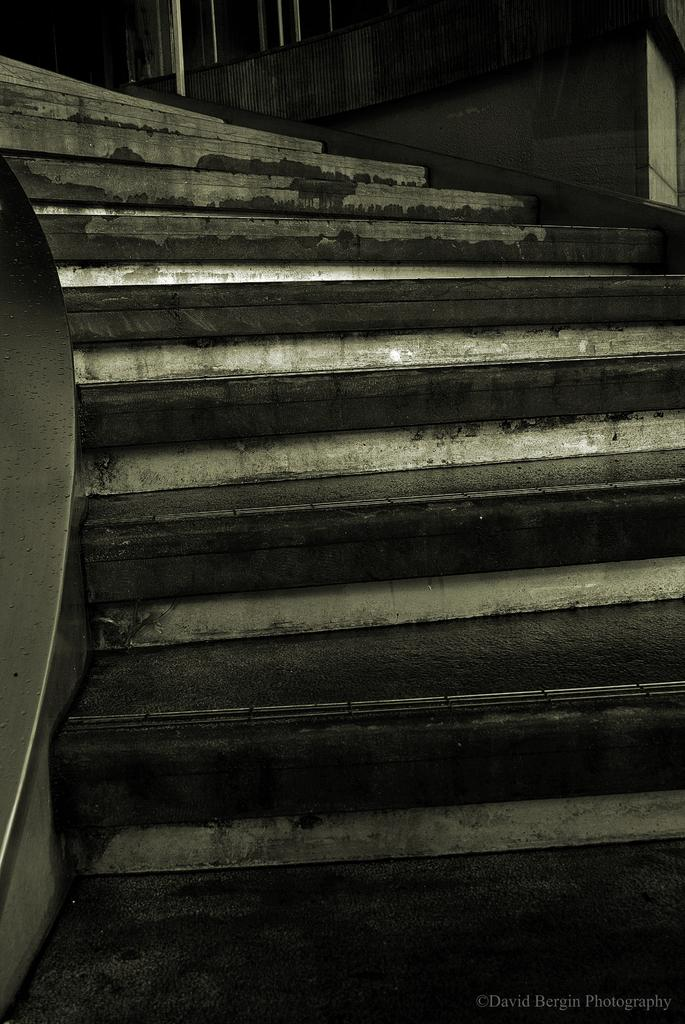What type of structure is visible in the image? There are stairs in the image. What is used to support the stairs? There is a staircase holder in the image. What is the background of the image made of? There is a wall in the image. Is there any additional marking on the image? Yes, there is a watermark on the image. What type of scent can be detected in the image? There is no scent present in the image, as it is a visual representation. 